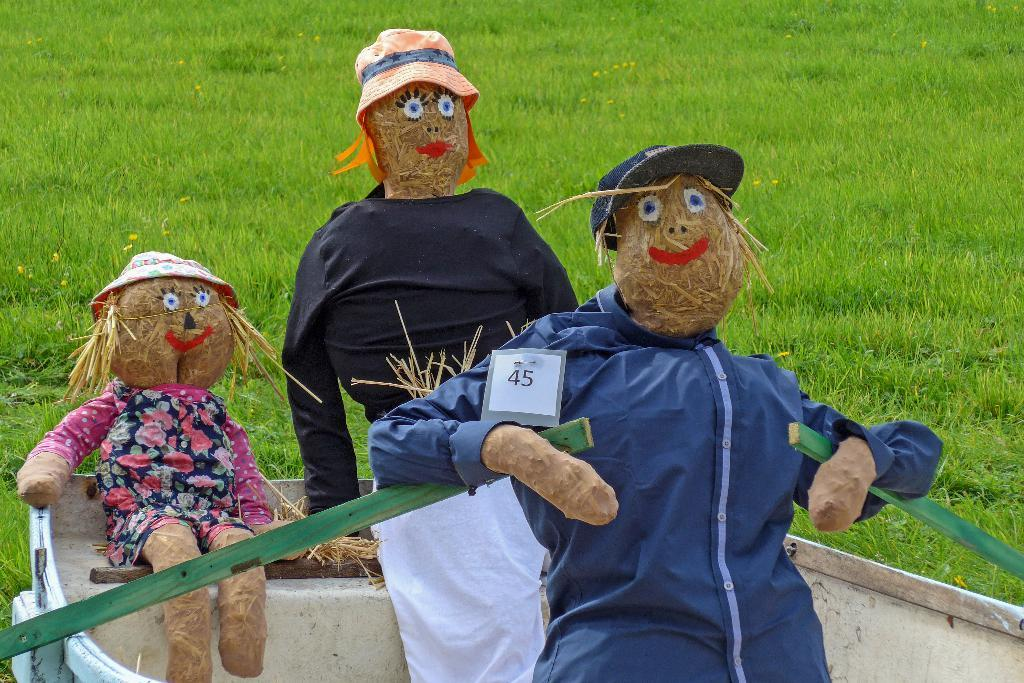How many puppets are in the image? There are three puppets in the image. What are the puppets wearing? The puppets are wearing clothes. What accessories are the puppets wearing on their heads? The puppets have caps on their heads. Where are the puppets located in the image? The puppets are placed in a boat. What type of vegetation can be seen in the background of the image? There is green-colored grass in the background of the image. Can you tell me how many planes are flying over the puppets in the image? There are no planes visible in the image; it only features three puppets in a boat. Is there a rabbit present in the image? No, there is no rabbit present in the image; it only features three puppets in a boat. 